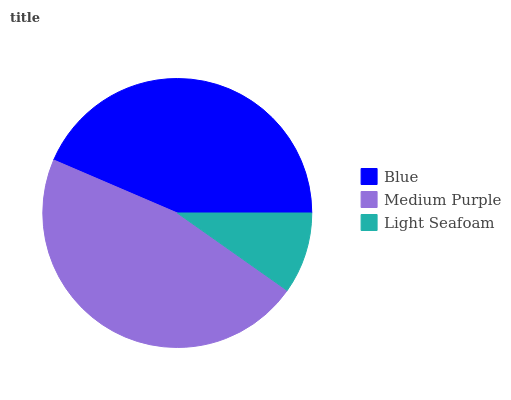Is Light Seafoam the minimum?
Answer yes or no. Yes. Is Medium Purple the maximum?
Answer yes or no. Yes. Is Medium Purple the minimum?
Answer yes or no. No. Is Light Seafoam the maximum?
Answer yes or no. No. Is Medium Purple greater than Light Seafoam?
Answer yes or no. Yes. Is Light Seafoam less than Medium Purple?
Answer yes or no. Yes. Is Light Seafoam greater than Medium Purple?
Answer yes or no. No. Is Medium Purple less than Light Seafoam?
Answer yes or no. No. Is Blue the high median?
Answer yes or no. Yes. Is Blue the low median?
Answer yes or no. Yes. Is Medium Purple the high median?
Answer yes or no. No. Is Medium Purple the low median?
Answer yes or no. No. 